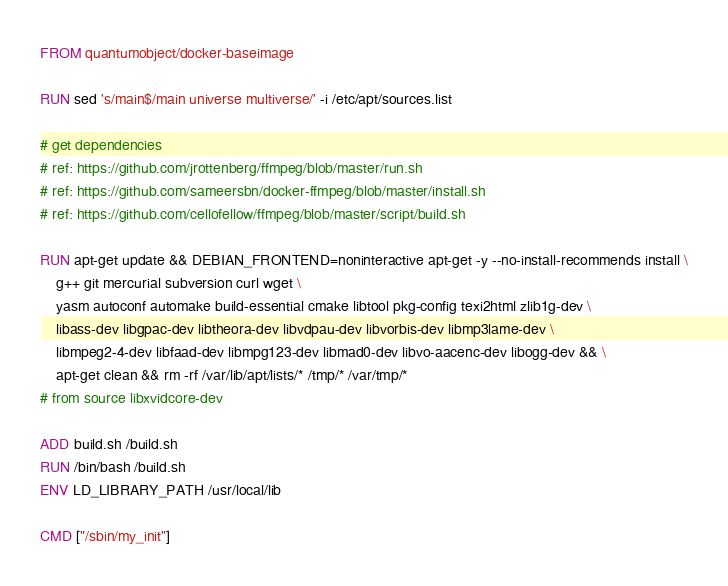Convert code to text. <code><loc_0><loc_0><loc_500><loc_500><_Dockerfile_>FROM quantumobject/docker-baseimage

RUN sed 's/main$/main universe multiverse/' -i /etc/apt/sources.list

# get dependencies
# ref: https://github.com/jrottenberg/ffmpeg/blob/master/run.sh
# ref: https://github.com/sameersbn/docker-ffmpeg/blob/master/install.sh
# ref: https://github.com/cellofellow/ffmpeg/blob/master/script/build.sh

RUN apt-get update && DEBIAN_FRONTEND=noninteractive apt-get -y --no-install-recommends install \
    g++ git mercurial subversion curl wget \
    yasm autoconf automake build-essential cmake libtool pkg-config texi2html zlib1g-dev \
    libass-dev libgpac-dev libtheora-dev libvdpau-dev libvorbis-dev libmp3lame-dev \
    libmpeg2-4-dev libfaad-dev libmpg123-dev libmad0-dev libvo-aacenc-dev libogg-dev && \
    apt-get clean && rm -rf /var/lib/apt/lists/* /tmp/* /var/tmp/*
# from source libxvidcore-dev

ADD build.sh /build.sh
RUN /bin/bash /build.sh
ENV LD_LIBRARY_PATH /usr/local/lib

CMD ["/sbin/my_init"]
</code> 